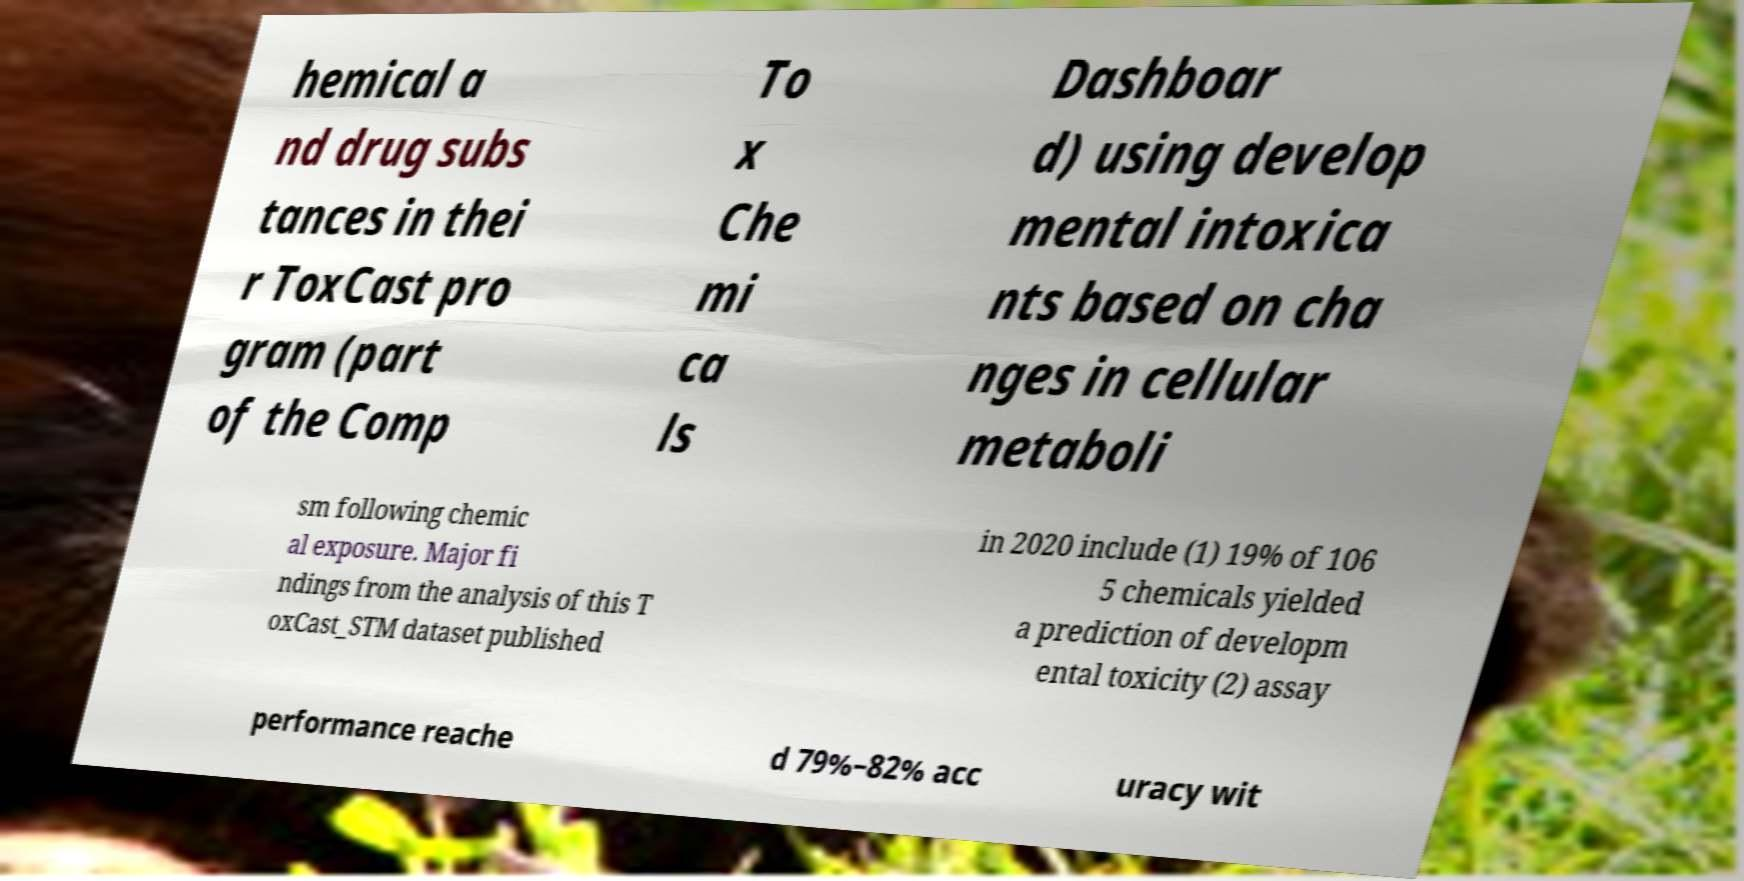Please identify and transcribe the text found in this image. hemical a nd drug subs tances in thei r ToxCast pro gram (part of the Comp To x Che mi ca ls Dashboar d) using develop mental intoxica nts based on cha nges in cellular metaboli sm following chemic al exposure. Major fi ndings from the analysis of this T oxCast_STM dataset published in 2020 include (1) 19% of 106 5 chemicals yielded a prediction of developm ental toxicity (2) assay performance reache d 79%–82% acc uracy wit 